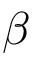<formula> <loc_0><loc_0><loc_500><loc_500>\beta</formula> 